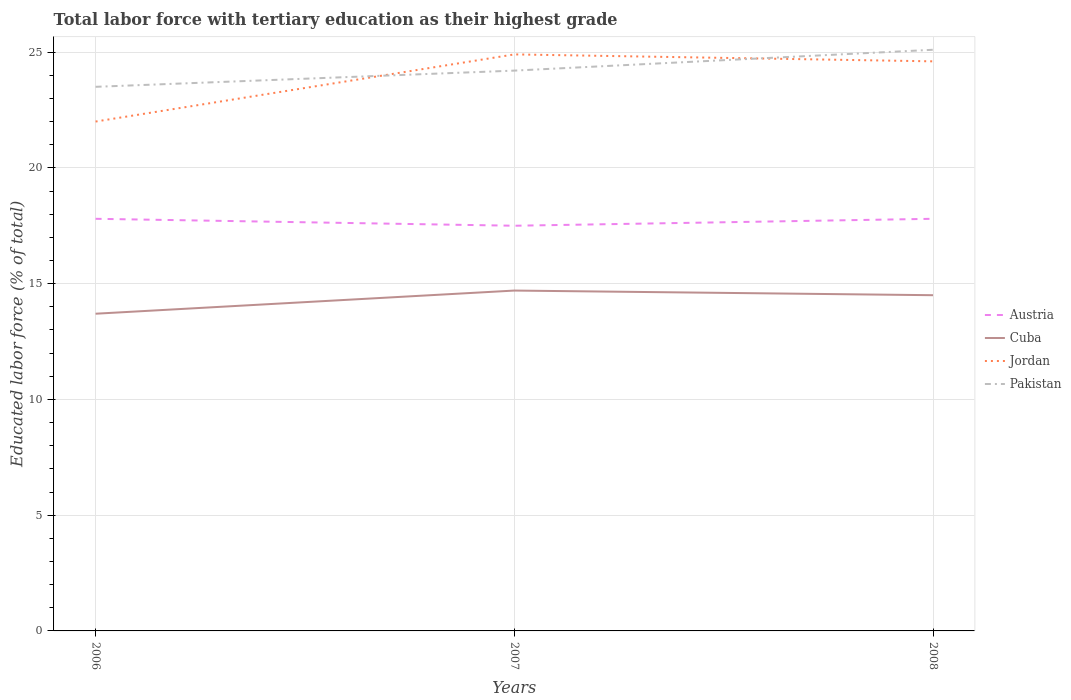Is the number of lines equal to the number of legend labels?
Offer a terse response. Yes. Across all years, what is the maximum percentage of male labor force with tertiary education in Jordan?
Your answer should be compact. 22. What is the total percentage of male labor force with tertiary education in Austria in the graph?
Provide a short and direct response. 0.3. What is the difference between the highest and the second highest percentage of male labor force with tertiary education in Austria?
Make the answer very short. 0.3. Is the percentage of male labor force with tertiary education in Pakistan strictly greater than the percentage of male labor force with tertiary education in Austria over the years?
Offer a very short reply. No. How many years are there in the graph?
Give a very brief answer. 3. What is the difference between two consecutive major ticks on the Y-axis?
Provide a short and direct response. 5. Does the graph contain grids?
Provide a short and direct response. Yes. Where does the legend appear in the graph?
Your response must be concise. Center right. What is the title of the graph?
Keep it short and to the point. Total labor force with tertiary education as their highest grade. Does "Kyrgyz Republic" appear as one of the legend labels in the graph?
Your answer should be very brief. No. What is the label or title of the X-axis?
Provide a short and direct response. Years. What is the label or title of the Y-axis?
Your answer should be compact. Educated labor force (% of total). What is the Educated labor force (% of total) in Austria in 2006?
Offer a terse response. 17.8. What is the Educated labor force (% of total) in Cuba in 2006?
Offer a very short reply. 13.7. What is the Educated labor force (% of total) in Pakistan in 2006?
Keep it short and to the point. 23.5. What is the Educated labor force (% of total) of Austria in 2007?
Offer a terse response. 17.5. What is the Educated labor force (% of total) of Cuba in 2007?
Provide a short and direct response. 14.7. What is the Educated labor force (% of total) in Jordan in 2007?
Provide a short and direct response. 24.9. What is the Educated labor force (% of total) of Pakistan in 2007?
Your answer should be compact. 24.2. What is the Educated labor force (% of total) of Austria in 2008?
Your answer should be compact. 17.8. What is the Educated labor force (% of total) of Cuba in 2008?
Offer a very short reply. 14.5. What is the Educated labor force (% of total) in Jordan in 2008?
Provide a succinct answer. 24.6. What is the Educated labor force (% of total) in Pakistan in 2008?
Your answer should be compact. 25.1. Across all years, what is the maximum Educated labor force (% of total) of Austria?
Provide a succinct answer. 17.8. Across all years, what is the maximum Educated labor force (% of total) in Cuba?
Your response must be concise. 14.7. Across all years, what is the maximum Educated labor force (% of total) of Jordan?
Make the answer very short. 24.9. Across all years, what is the maximum Educated labor force (% of total) in Pakistan?
Offer a very short reply. 25.1. Across all years, what is the minimum Educated labor force (% of total) of Cuba?
Provide a succinct answer. 13.7. Across all years, what is the minimum Educated labor force (% of total) of Pakistan?
Make the answer very short. 23.5. What is the total Educated labor force (% of total) of Austria in the graph?
Offer a terse response. 53.1. What is the total Educated labor force (% of total) of Cuba in the graph?
Provide a succinct answer. 42.9. What is the total Educated labor force (% of total) in Jordan in the graph?
Your answer should be very brief. 71.5. What is the total Educated labor force (% of total) of Pakistan in the graph?
Give a very brief answer. 72.8. What is the difference between the Educated labor force (% of total) in Jordan in 2006 and that in 2007?
Offer a very short reply. -2.9. What is the difference between the Educated labor force (% of total) of Austria in 2006 and that in 2008?
Provide a succinct answer. 0. What is the difference between the Educated labor force (% of total) in Cuba in 2006 and that in 2008?
Offer a very short reply. -0.8. What is the difference between the Educated labor force (% of total) in Cuba in 2007 and that in 2008?
Offer a very short reply. 0.2. What is the difference between the Educated labor force (% of total) in Jordan in 2007 and that in 2008?
Your answer should be very brief. 0.3. What is the difference between the Educated labor force (% of total) in Pakistan in 2007 and that in 2008?
Your answer should be very brief. -0.9. What is the difference between the Educated labor force (% of total) of Austria in 2006 and the Educated labor force (% of total) of Cuba in 2007?
Make the answer very short. 3.1. What is the difference between the Educated labor force (% of total) in Cuba in 2006 and the Educated labor force (% of total) in Jordan in 2007?
Your answer should be very brief. -11.2. What is the difference between the Educated labor force (% of total) of Cuba in 2006 and the Educated labor force (% of total) of Pakistan in 2007?
Provide a succinct answer. -10.5. What is the difference between the Educated labor force (% of total) of Jordan in 2006 and the Educated labor force (% of total) of Pakistan in 2007?
Give a very brief answer. -2.2. What is the difference between the Educated labor force (% of total) of Austria in 2006 and the Educated labor force (% of total) of Cuba in 2008?
Your response must be concise. 3.3. What is the difference between the Educated labor force (% of total) in Austria in 2006 and the Educated labor force (% of total) in Pakistan in 2008?
Offer a terse response. -7.3. What is the difference between the Educated labor force (% of total) in Cuba in 2006 and the Educated labor force (% of total) in Jordan in 2008?
Offer a very short reply. -10.9. What is the difference between the Educated labor force (% of total) of Cuba in 2006 and the Educated labor force (% of total) of Pakistan in 2008?
Provide a succinct answer. -11.4. What is the difference between the Educated labor force (% of total) in Jordan in 2006 and the Educated labor force (% of total) in Pakistan in 2008?
Keep it short and to the point. -3.1. What is the difference between the Educated labor force (% of total) in Austria in 2007 and the Educated labor force (% of total) in Cuba in 2008?
Give a very brief answer. 3. What is the difference between the Educated labor force (% of total) of Cuba in 2007 and the Educated labor force (% of total) of Jordan in 2008?
Your answer should be very brief. -9.9. What is the difference between the Educated labor force (% of total) in Cuba in 2007 and the Educated labor force (% of total) in Pakistan in 2008?
Your answer should be very brief. -10.4. What is the difference between the Educated labor force (% of total) in Jordan in 2007 and the Educated labor force (% of total) in Pakistan in 2008?
Your answer should be compact. -0.2. What is the average Educated labor force (% of total) of Jordan per year?
Offer a terse response. 23.83. What is the average Educated labor force (% of total) in Pakistan per year?
Offer a very short reply. 24.27. In the year 2006, what is the difference between the Educated labor force (% of total) of Austria and Educated labor force (% of total) of Pakistan?
Offer a very short reply. -5.7. In the year 2006, what is the difference between the Educated labor force (% of total) of Cuba and Educated labor force (% of total) of Jordan?
Keep it short and to the point. -8.3. In the year 2007, what is the difference between the Educated labor force (% of total) of Austria and Educated labor force (% of total) of Cuba?
Make the answer very short. 2.8. In the year 2007, what is the difference between the Educated labor force (% of total) in Austria and Educated labor force (% of total) in Jordan?
Keep it short and to the point. -7.4. In the year 2007, what is the difference between the Educated labor force (% of total) of Austria and Educated labor force (% of total) of Pakistan?
Offer a terse response. -6.7. In the year 2007, what is the difference between the Educated labor force (% of total) of Cuba and Educated labor force (% of total) of Jordan?
Your response must be concise. -10.2. In the year 2007, what is the difference between the Educated labor force (% of total) in Cuba and Educated labor force (% of total) in Pakistan?
Keep it short and to the point. -9.5. In the year 2008, what is the difference between the Educated labor force (% of total) in Austria and Educated labor force (% of total) in Cuba?
Provide a short and direct response. 3.3. In the year 2008, what is the difference between the Educated labor force (% of total) of Austria and Educated labor force (% of total) of Jordan?
Provide a short and direct response. -6.8. In the year 2008, what is the difference between the Educated labor force (% of total) in Jordan and Educated labor force (% of total) in Pakistan?
Your response must be concise. -0.5. What is the ratio of the Educated labor force (% of total) in Austria in 2006 to that in 2007?
Your response must be concise. 1.02. What is the ratio of the Educated labor force (% of total) of Cuba in 2006 to that in 2007?
Provide a short and direct response. 0.93. What is the ratio of the Educated labor force (% of total) of Jordan in 2006 to that in 2007?
Offer a terse response. 0.88. What is the ratio of the Educated labor force (% of total) in Pakistan in 2006 to that in 2007?
Your response must be concise. 0.97. What is the ratio of the Educated labor force (% of total) of Cuba in 2006 to that in 2008?
Provide a short and direct response. 0.94. What is the ratio of the Educated labor force (% of total) in Jordan in 2006 to that in 2008?
Your answer should be compact. 0.89. What is the ratio of the Educated labor force (% of total) of Pakistan in 2006 to that in 2008?
Your answer should be very brief. 0.94. What is the ratio of the Educated labor force (% of total) in Austria in 2007 to that in 2008?
Offer a terse response. 0.98. What is the ratio of the Educated labor force (% of total) of Cuba in 2007 to that in 2008?
Make the answer very short. 1.01. What is the ratio of the Educated labor force (% of total) in Jordan in 2007 to that in 2008?
Your answer should be compact. 1.01. What is the ratio of the Educated labor force (% of total) of Pakistan in 2007 to that in 2008?
Your answer should be compact. 0.96. What is the difference between the highest and the second highest Educated labor force (% of total) of Austria?
Your response must be concise. 0. What is the difference between the highest and the second highest Educated labor force (% of total) of Cuba?
Your answer should be compact. 0.2. What is the difference between the highest and the second highest Educated labor force (% of total) in Pakistan?
Provide a succinct answer. 0.9. What is the difference between the highest and the lowest Educated labor force (% of total) of Pakistan?
Give a very brief answer. 1.6. 